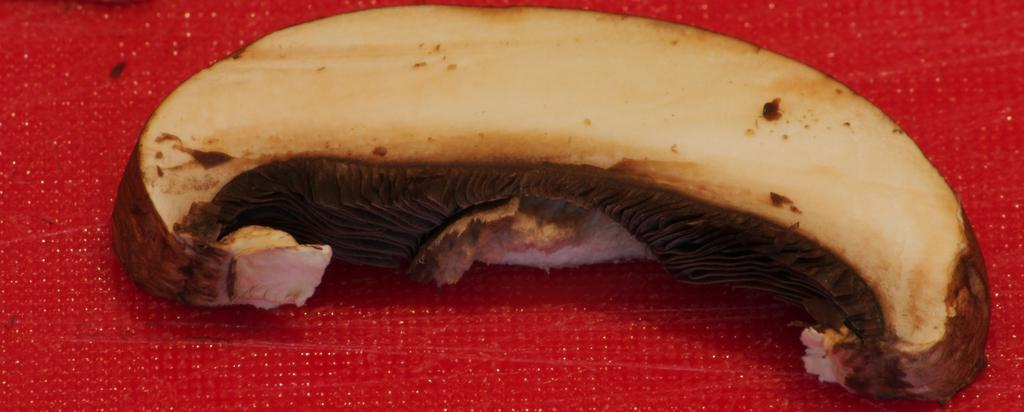What is the main subject of the image? The main subject of the image is food. What can be observed about the surface on which the food is placed? The food is on a red surface. What type of station is visible in the image? There is no station present in the image; it features food on a red surface. How far away is the quartz from the food in the image? There is no quartz present in the image, so it cannot be determined how far away it might be from the food. 